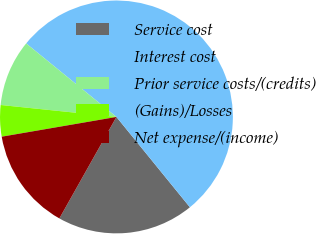Convert chart to OTSL. <chart><loc_0><loc_0><loc_500><loc_500><pie_chart><fcel>Service cost<fcel>Interest cost<fcel>Prior service costs/(credits)<fcel>(Gains)/Losses<fcel>Net expense/(income)<nl><fcel>19.02%<fcel>53.25%<fcel>9.24%<fcel>4.35%<fcel>14.13%<nl></chart> 